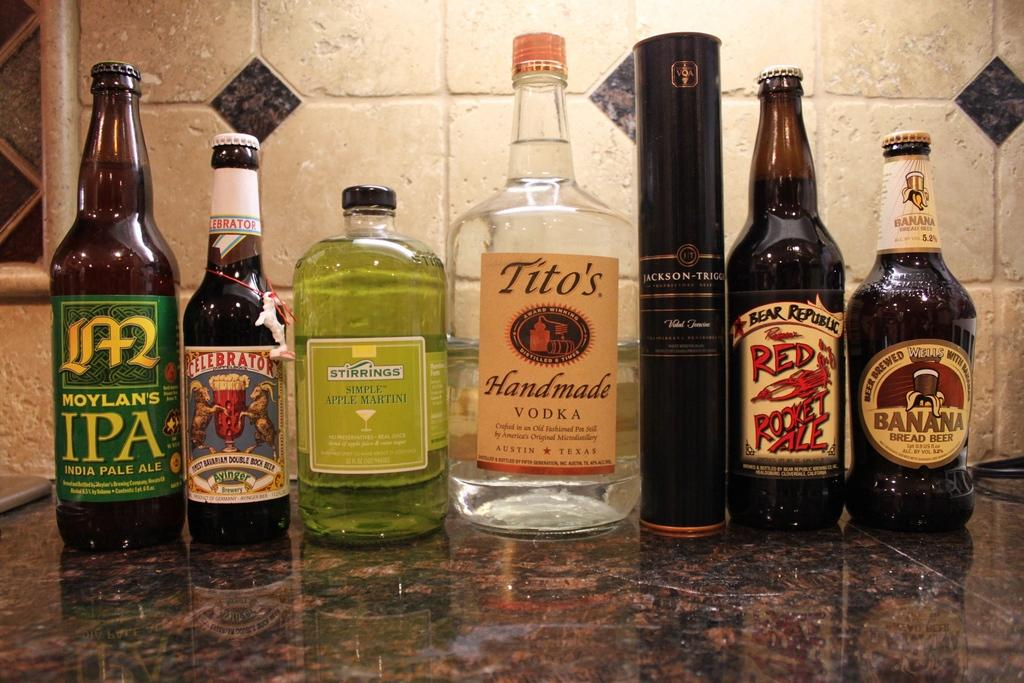<image>
Share a concise interpretation of the image provided. A bottle of Hoylan's IPA is on a counter in a row of bottles of alcohol. 